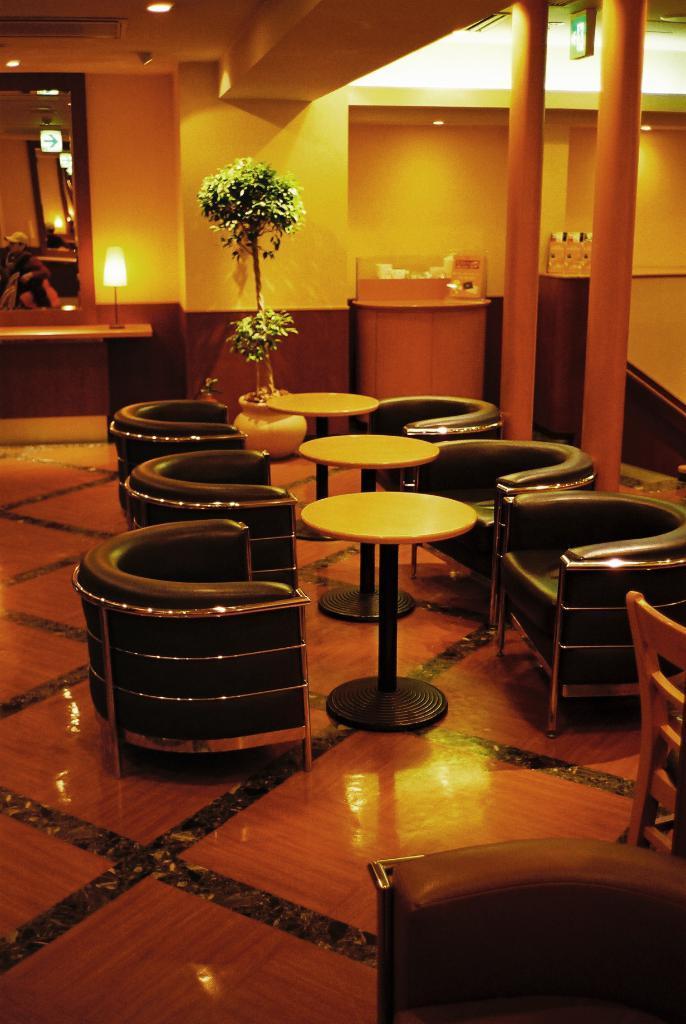Describe this image in one or two sentences. In the picture we can see three round tables and six chairs and behind it we can see a plant and beside it we can see a desk with lamp and on the other desk with a box on it and beside it we can see two pillars and to the ceiling we can see light. 